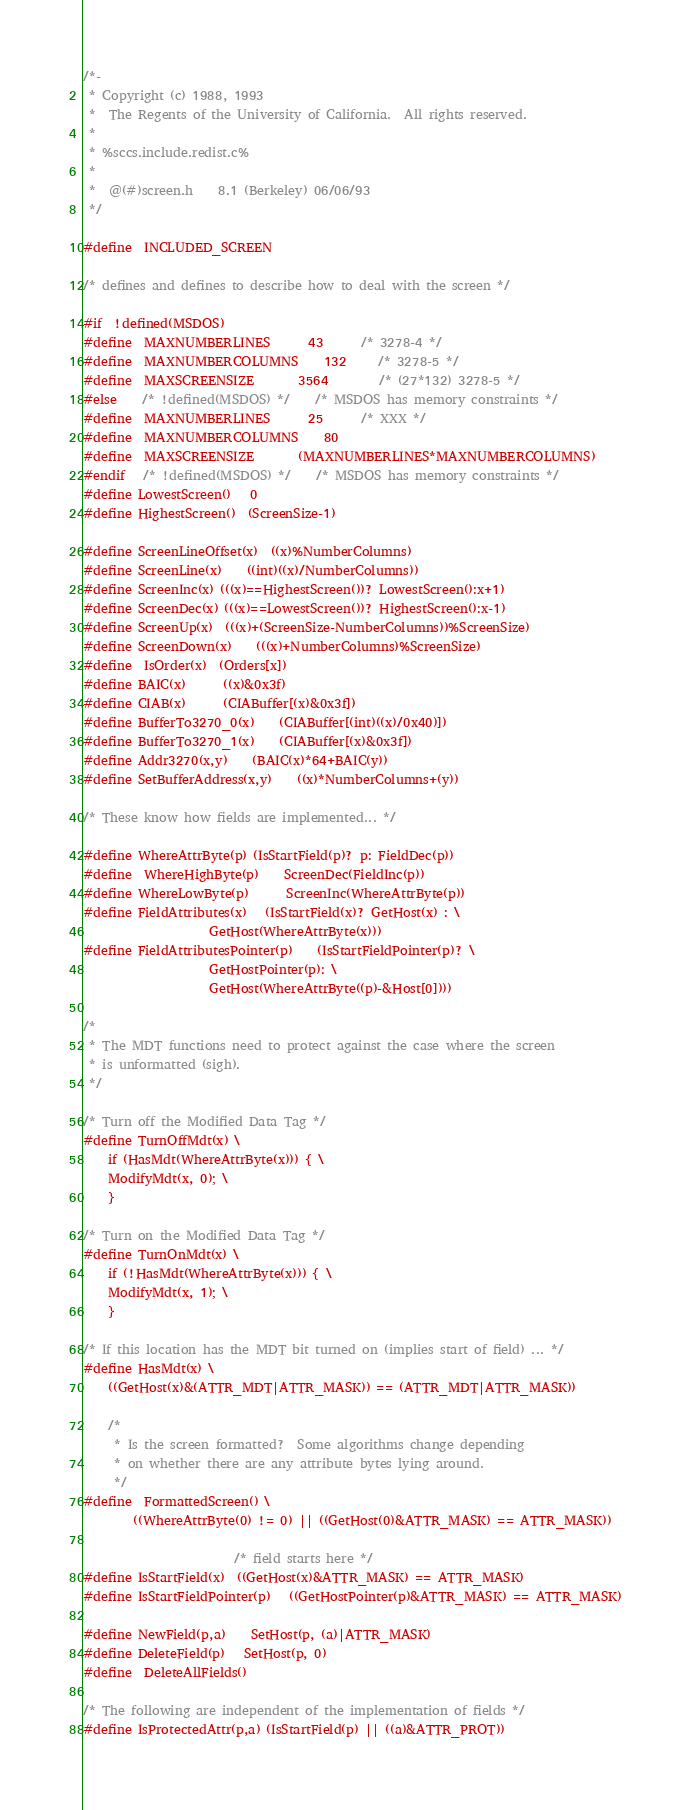Convert code to text. <code><loc_0><loc_0><loc_500><loc_500><_C_>/*-
 * Copyright (c) 1988, 1993
 *	The Regents of the University of California.  All rights reserved.
 *
 * %sccs.include.redist.c%
 *
 *	@(#)screen.h	8.1 (Berkeley) 06/06/93
 */

#define	INCLUDED_SCREEN

/* defines and defines to describe how to deal with the screen */

#if	!defined(MSDOS)
#define	MAXNUMBERLINES		43		/* 3278-4 */
#define	MAXNUMBERCOLUMNS	132		/* 3278-5 */
#define	MAXSCREENSIZE		3564		/* (27*132) 3278-5 */
#else	/* !defined(MSDOS) */	/* MSDOS has memory constraints */
#define	MAXNUMBERLINES		25		/* XXX */
#define	MAXNUMBERCOLUMNS	80
#define	MAXSCREENSIZE		(MAXNUMBERLINES*MAXNUMBERCOLUMNS)
#endif	/* !defined(MSDOS) */	/* MSDOS has memory constraints */
#define LowestScreen()	0
#define HighestScreen()	(ScreenSize-1)

#define ScreenLineOffset(x)	((x)%NumberColumns)
#define ScreenLine(x)	((int)((x)/NumberColumns))
#define ScreenInc(x)	(((x)==HighestScreen())? LowestScreen():x+1)
#define ScreenDec(x)	(((x)==LowestScreen())? HighestScreen():x-1)
#define ScreenUp(x)	(((x)+(ScreenSize-NumberColumns))%ScreenSize)
#define ScreenDown(x)	(((x)+NumberColumns)%ScreenSize)
#define	IsOrder(x)	(Orders[x])
#define BAIC(x)		((x)&0x3f)
#define CIAB(x)		(CIABuffer[(x)&0x3f])
#define BufferTo3270_0(x)	(CIABuffer[(int)((x)/0x40)])
#define BufferTo3270_1(x)	(CIABuffer[(x)&0x3f])
#define Addr3270(x,y)	(BAIC(x)*64+BAIC(y))
#define SetBufferAddress(x,y)	((x)*NumberColumns+(y))

/* These know how fields are implemented... */

#define WhereAttrByte(p)	(IsStartField(p)? p: FieldDec(p))
#define	WhereHighByte(p)	ScreenDec(FieldInc(p))
#define WhereLowByte(p)		ScreenInc(WhereAttrByte(p))
#define FieldAttributes(x)	(IsStartField(x)? GetHost(x) : \
				    GetHost(WhereAttrByte(x)))
#define FieldAttributesPointer(p)	(IsStartFieldPointer(p)? \
				    GetHostPointer(p): \
				    GetHost(WhereAttrByte((p)-&Host[0])))

/*
 * The MDT functions need to protect against the case where the screen
 * is unformatted (sigh).
 */

/* Turn off the Modified Data Tag */
#define TurnOffMdt(x) \
    if (HasMdt(WhereAttrByte(x))) { \
	ModifyMdt(x, 0); \
    }

/* Turn on the Modified Data Tag */
#define TurnOnMdt(x) \
    if (!HasMdt(WhereAttrByte(x))) { \
	ModifyMdt(x, 1); \
    }

/* If this location has the MDT bit turned on (implies start of field) ... */
#define HasMdt(x) \
    ((GetHost(x)&(ATTR_MDT|ATTR_MASK)) == (ATTR_MDT|ATTR_MASK))

	/*
	 * Is the screen formatted?  Some algorithms change depending
	 * on whether there are any attribute bytes lying around.
	 */
#define	FormattedScreen() \
	    ((WhereAttrByte(0) != 0) || ((GetHost(0)&ATTR_MASK) == ATTR_MASK))

					    /* field starts here */
#define IsStartField(x)	((GetHost(x)&ATTR_MASK) == ATTR_MASK)
#define IsStartFieldPointer(p)	((GetHostPointer(p)&ATTR_MASK) == ATTR_MASK)

#define NewField(p,a)	SetHost(p, (a)|ATTR_MASK)
#define DeleteField(p)	SetHost(p, 0)
#define	DeleteAllFields()

/* The following are independent of the implementation of fields */
#define IsProtectedAttr(p,a)	(IsStartField(p) || ((a)&ATTR_PROT))</code> 